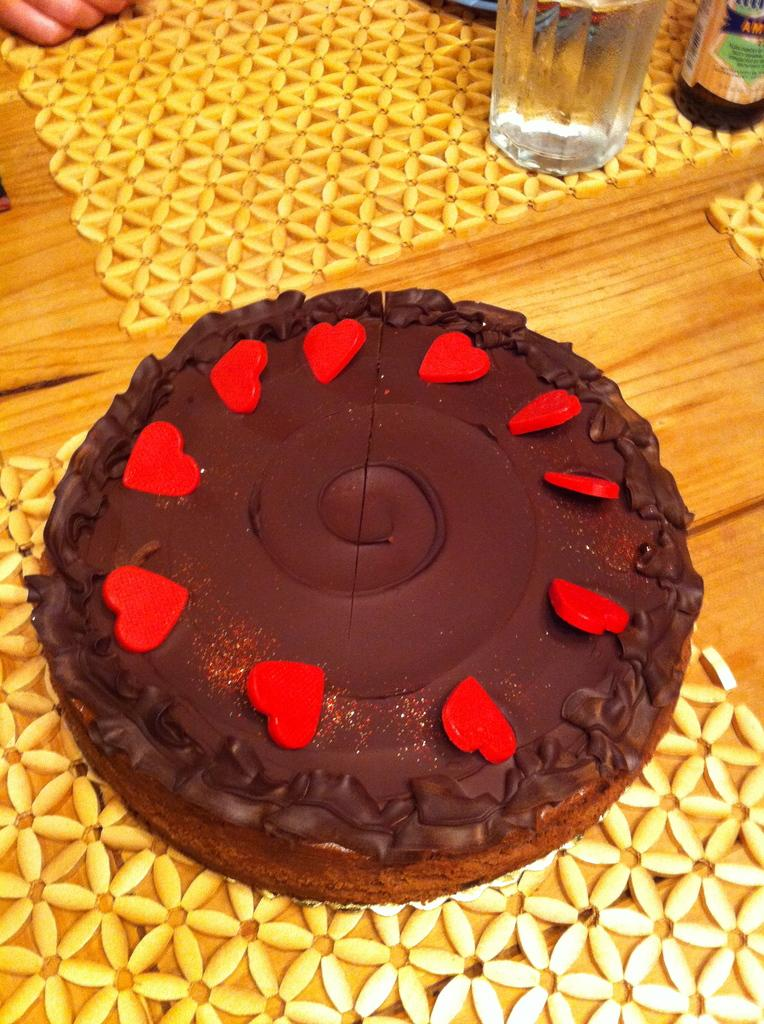What type of furniture is present in the image? There is a table in the image. What is placed on the table? There are two mats, a cake, and a glass on the table. What type of patch can be seen on the cake in the image? There is no patch visible on the cake in the image. What type of jewel is placed on the throne in the image? There is no throne present in the image. 